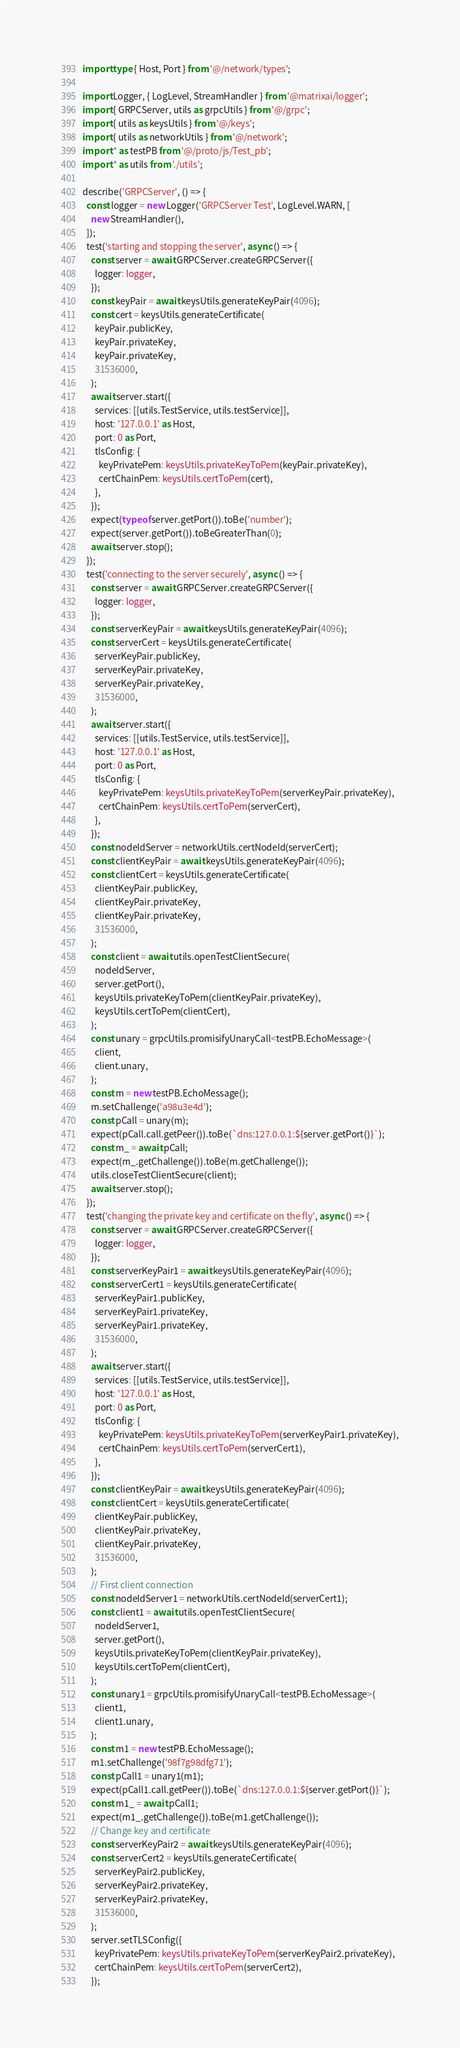<code> <loc_0><loc_0><loc_500><loc_500><_TypeScript_>import type { Host, Port } from '@/network/types';

import Logger, { LogLevel, StreamHandler } from '@matrixai/logger';
import { GRPCServer, utils as grpcUtils } from '@/grpc';
import { utils as keysUtils } from '@/keys';
import { utils as networkUtils } from '@/network';
import * as testPB from '@/proto/js/Test_pb';
import * as utils from './utils';

describe('GRPCServer', () => {
  const logger = new Logger('GRPCServer Test', LogLevel.WARN, [
    new StreamHandler(),
  ]);
  test('starting and stopping the server', async () => {
    const server = await GRPCServer.createGRPCServer({
      logger: logger,
    });
    const keyPair = await keysUtils.generateKeyPair(4096);
    const cert = keysUtils.generateCertificate(
      keyPair.publicKey,
      keyPair.privateKey,
      keyPair.privateKey,
      31536000,
    );
    await server.start({
      services: [[utils.TestService, utils.testService]],
      host: '127.0.0.1' as Host,
      port: 0 as Port,
      tlsConfig: {
        keyPrivatePem: keysUtils.privateKeyToPem(keyPair.privateKey),
        certChainPem: keysUtils.certToPem(cert),
      },
    });
    expect(typeof server.getPort()).toBe('number');
    expect(server.getPort()).toBeGreaterThan(0);
    await server.stop();
  });
  test('connecting to the server securely', async () => {
    const server = await GRPCServer.createGRPCServer({
      logger: logger,
    });
    const serverKeyPair = await keysUtils.generateKeyPair(4096);
    const serverCert = keysUtils.generateCertificate(
      serverKeyPair.publicKey,
      serverKeyPair.privateKey,
      serverKeyPair.privateKey,
      31536000,
    );
    await server.start({
      services: [[utils.TestService, utils.testService]],
      host: '127.0.0.1' as Host,
      port: 0 as Port,
      tlsConfig: {
        keyPrivatePem: keysUtils.privateKeyToPem(serverKeyPair.privateKey),
        certChainPem: keysUtils.certToPem(serverCert),
      },
    });
    const nodeIdServer = networkUtils.certNodeId(serverCert);
    const clientKeyPair = await keysUtils.generateKeyPair(4096);
    const clientCert = keysUtils.generateCertificate(
      clientKeyPair.publicKey,
      clientKeyPair.privateKey,
      clientKeyPair.privateKey,
      31536000,
    );
    const client = await utils.openTestClientSecure(
      nodeIdServer,
      server.getPort(),
      keysUtils.privateKeyToPem(clientKeyPair.privateKey),
      keysUtils.certToPem(clientCert),
    );
    const unary = grpcUtils.promisifyUnaryCall<testPB.EchoMessage>(
      client,
      client.unary,
    );
    const m = new testPB.EchoMessage();
    m.setChallenge('a98u3e4d');
    const pCall = unary(m);
    expect(pCall.call.getPeer()).toBe(`dns:127.0.0.1:${server.getPort()}`);
    const m_ = await pCall;
    expect(m_.getChallenge()).toBe(m.getChallenge());
    utils.closeTestClientSecure(client);
    await server.stop();
  });
  test('changing the private key and certificate on the fly', async () => {
    const server = await GRPCServer.createGRPCServer({
      logger: logger,
    });
    const serverKeyPair1 = await keysUtils.generateKeyPair(4096);
    const serverCert1 = keysUtils.generateCertificate(
      serverKeyPair1.publicKey,
      serverKeyPair1.privateKey,
      serverKeyPair1.privateKey,
      31536000,
    );
    await server.start({
      services: [[utils.TestService, utils.testService]],
      host: '127.0.0.1' as Host,
      port: 0 as Port,
      tlsConfig: {
        keyPrivatePem: keysUtils.privateKeyToPem(serverKeyPair1.privateKey),
        certChainPem: keysUtils.certToPem(serverCert1),
      },
    });
    const clientKeyPair = await keysUtils.generateKeyPair(4096);
    const clientCert = keysUtils.generateCertificate(
      clientKeyPair.publicKey,
      clientKeyPair.privateKey,
      clientKeyPair.privateKey,
      31536000,
    );
    // First client connection
    const nodeIdServer1 = networkUtils.certNodeId(serverCert1);
    const client1 = await utils.openTestClientSecure(
      nodeIdServer1,
      server.getPort(),
      keysUtils.privateKeyToPem(clientKeyPair.privateKey),
      keysUtils.certToPem(clientCert),
    );
    const unary1 = grpcUtils.promisifyUnaryCall<testPB.EchoMessage>(
      client1,
      client1.unary,
    );
    const m1 = new testPB.EchoMessage();
    m1.setChallenge('98f7g98dfg71');
    const pCall1 = unary1(m1);
    expect(pCall1.call.getPeer()).toBe(`dns:127.0.0.1:${server.getPort()}`);
    const m1_ = await pCall1;
    expect(m1_.getChallenge()).toBe(m1.getChallenge());
    // Change key and certificate
    const serverKeyPair2 = await keysUtils.generateKeyPair(4096);
    const serverCert2 = keysUtils.generateCertificate(
      serverKeyPair2.publicKey,
      serverKeyPair2.privateKey,
      serverKeyPair2.privateKey,
      31536000,
    );
    server.setTLSConfig({
      keyPrivatePem: keysUtils.privateKeyToPem(serverKeyPair2.privateKey),
      certChainPem: keysUtils.certToPem(serverCert2),
    });</code> 